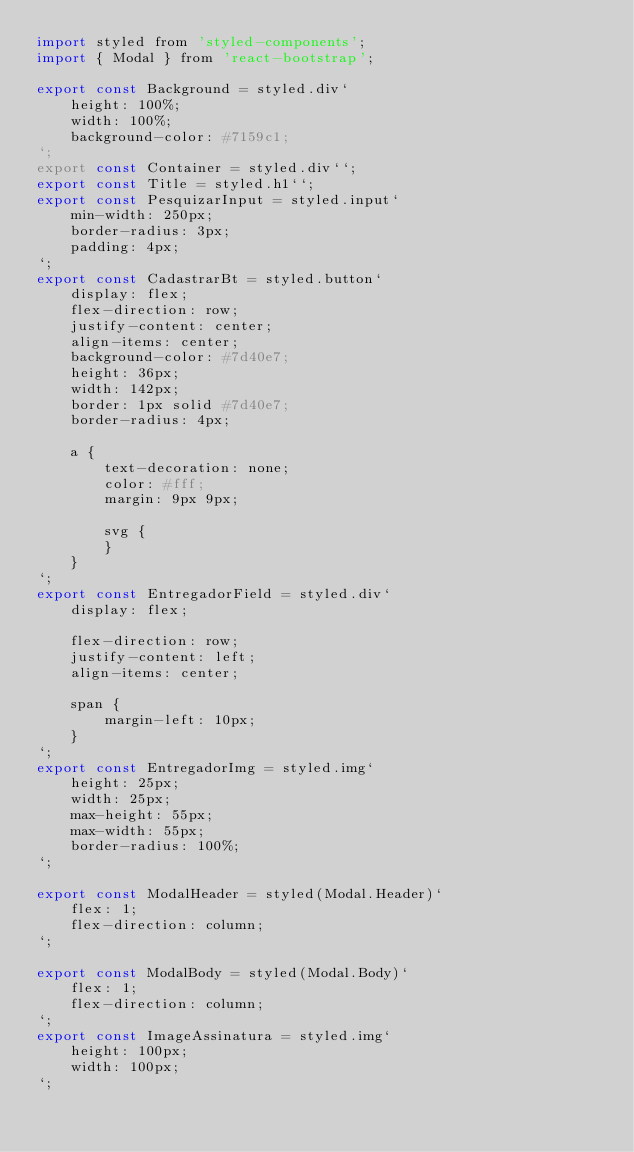Convert code to text. <code><loc_0><loc_0><loc_500><loc_500><_JavaScript_>import styled from 'styled-components';
import { Modal } from 'react-bootstrap';

export const Background = styled.div`
    height: 100%;
    width: 100%;
    background-color: #7159c1;
`;
export const Container = styled.div``;
export const Title = styled.h1``;
export const PesquizarInput = styled.input`
    min-width: 250px;
    border-radius: 3px;
    padding: 4px;
`;
export const CadastrarBt = styled.button`
    display: flex;
    flex-direction: row;
    justify-content: center;
    align-items: center;
    background-color: #7d40e7;
    height: 36px;
    width: 142px;
    border: 1px solid #7d40e7;
    border-radius: 4px;

    a {
        text-decoration: none;
        color: #fff;
        margin: 9px 9px;

        svg {
        }
    }
`;
export const EntregadorField = styled.div`
    display: flex;

    flex-direction: row;
    justify-content: left;
    align-items: center;

    span {
        margin-left: 10px;
    }
`;
export const EntregadorImg = styled.img`
    height: 25px;
    width: 25px;
    max-height: 55px;
    max-width: 55px;
    border-radius: 100%;
`;

export const ModalHeader = styled(Modal.Header)`
    flex: 1;
    flex-direction: column;
`;

export const ModalBody = styled(Modal.Body)`
    flex: 1;
    flex-direction: column;
`;
export const ImageAssinatura = styled.img`
    height: 100px;
    width: 100px;
`;
</code> 